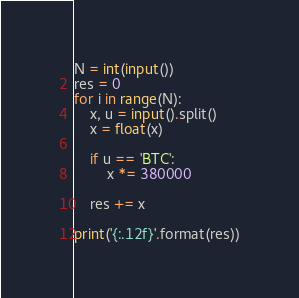<code> <loc_0><loc_0><loc_500><loc_500><_Python_>N = int(input())
res = 0
for i in range(N):
    x, u = input().split()
    x = float(x)

    if u == 'BTC':
        x *= 380000

    res += x

print('{:.12f}'.format(res))
</code> 